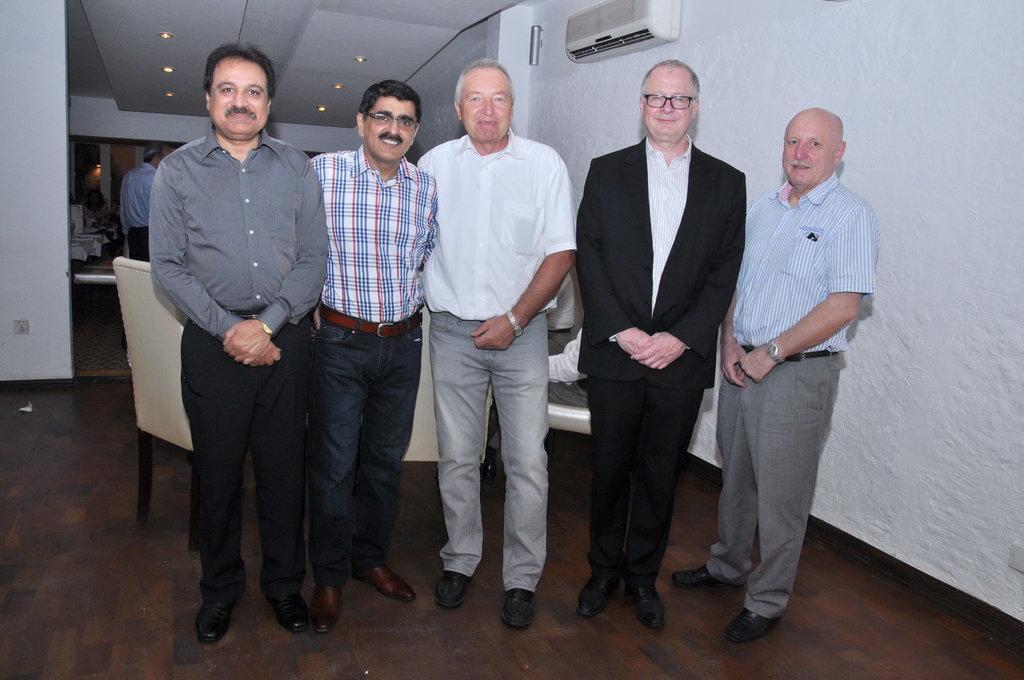Could you give a brief overview of what you see in this image? In the image we can see five men standing, wearing clothes, shoes and some of them are wearing spectacles and a wrist watch. Behind them there are chairs and other people. Here we can see the floor, wall and lights. 